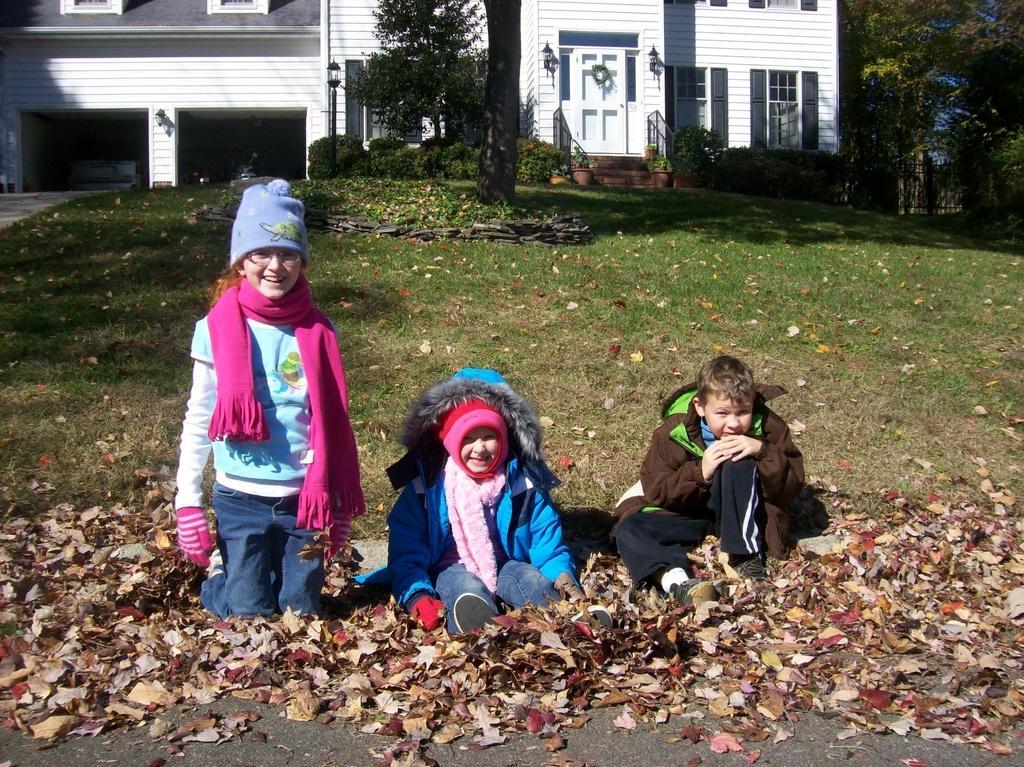How would you summarize this image in a sentence or two? In the middle of the image three children are sitting and smiling. Behind them there is grass and plants and trees and building. At the bottom of the image there are some leaves. 